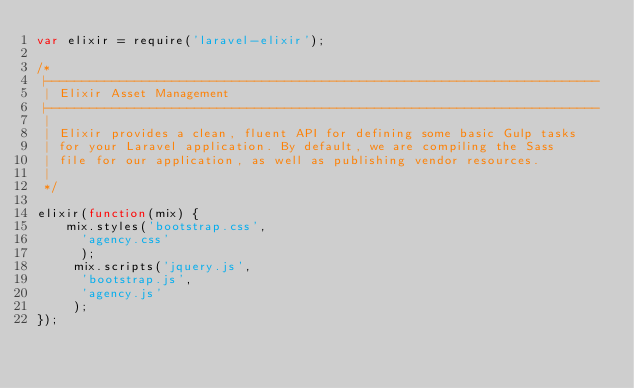Convert code to text. <code><loc_0><loc_0><loc_500><loc_500><_JavaScript_>var elixir = require('laravel-elixir');

/*
 |--------------------------------------------------------------------------
 | Elixir Asset Management
 |--------------------------------------------------------------------------
 |
 | Elixir provides a clean, fluent API for defining some basic Gulp tasks
 | for your Laravel application. By default, we are compiling the Sass
 | file for our application, as well as publishing vendor resources.
 |
 */

elixir(function(mix) {
    mix.styles('bootstrap.css',
    	'agency.css'
    	);
     mix.scripts('jquery.js',
     	'bootstrap.js',
     	'agency.js'
     );
});
</code> 